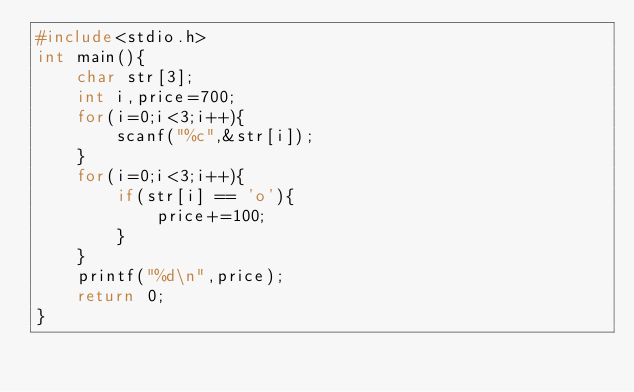<code> <loc_0><loc_0><loc_500><loc_500><_C_>#include<stdio.h>
int main(){
    char str[3];
    int i,price=700;
    for(i=0;i<3;i++){
        scanf("%c",&str[i]);
    }
    for(i=0;i<3;i++){
        if(str[i] == 'o'){
            price+=100;
        }
    }
    printf("%d\n",price);
    return 0;
}
</code> 